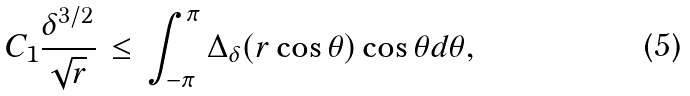<formula> <loc_0><loc_0><loc_500><loc_500>C _ { 1 } \frac { \delta ^ { 3 / 2 } } { \sqrt { r } } \, \leq \, \int _ { - \pi } ^ { \pi } \Delta _ { \delta } ( r \cos \theta ) \cos \theta d \theta ,</formula> 